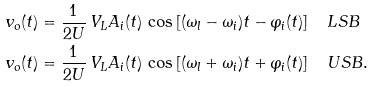<formula> <loc_0><loc_0><loc_500><loc_500>v _ { o } ( t ) & = \frac { 1 } { 2 U } \, V _ { L } A _ { i } ( t ) \, \cos \left [ ( \omega _ { l } - \omega _ { i } ) t - \varphi _ { i } ( t ) \right ] \quad L S B \\ v _ { o } ( t ) & = \frac { 1 } { 2 U } \, V _ { L } A _ { i } ( t ) \, \cos \left [ ( \omega _ { l } + \omega _ { i } ) t + \varphi _ { i } ( t ) \right ] \quad U S B .</formula> 